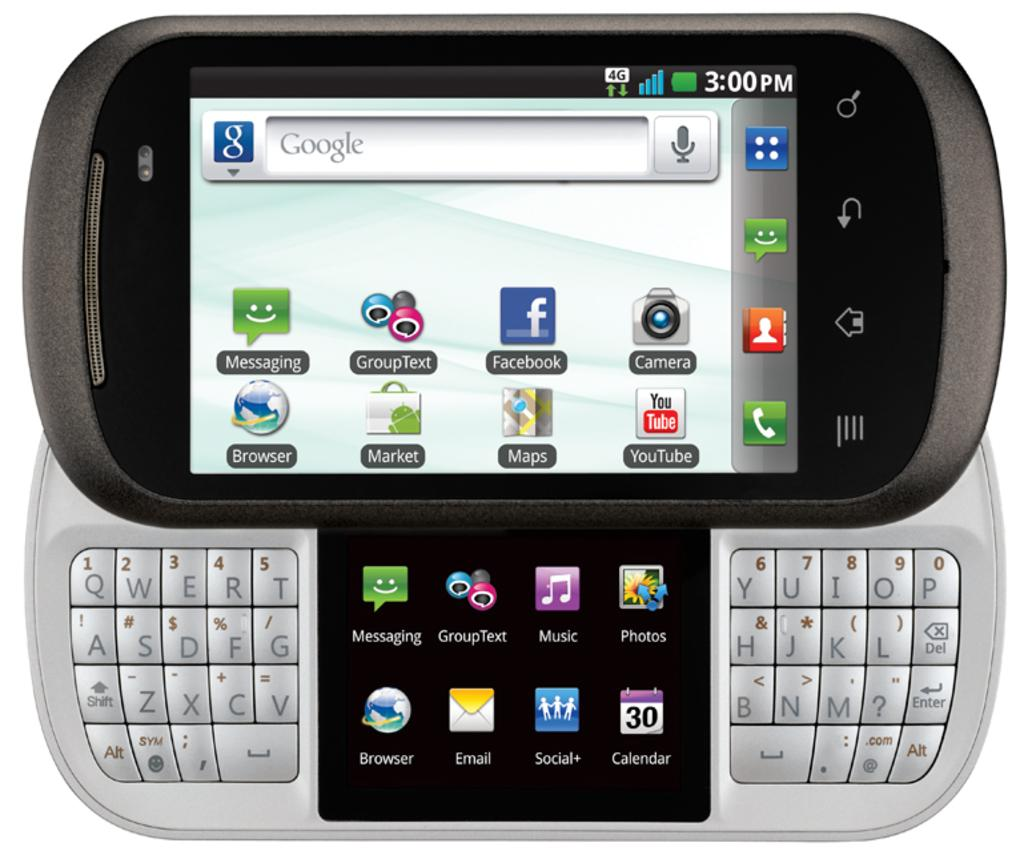Provide a one-sentence caption for the provided image. some apps that include a messaging app on it. 